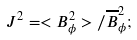Convert formula to latex. <formula><loc_0><loc_0><loc_500><loc_500>J ^ { 2 } = < B _ { \phi } ^ { 2 } > / \overline { B } _ { \phi } ^ { 2 } ;</formula> 